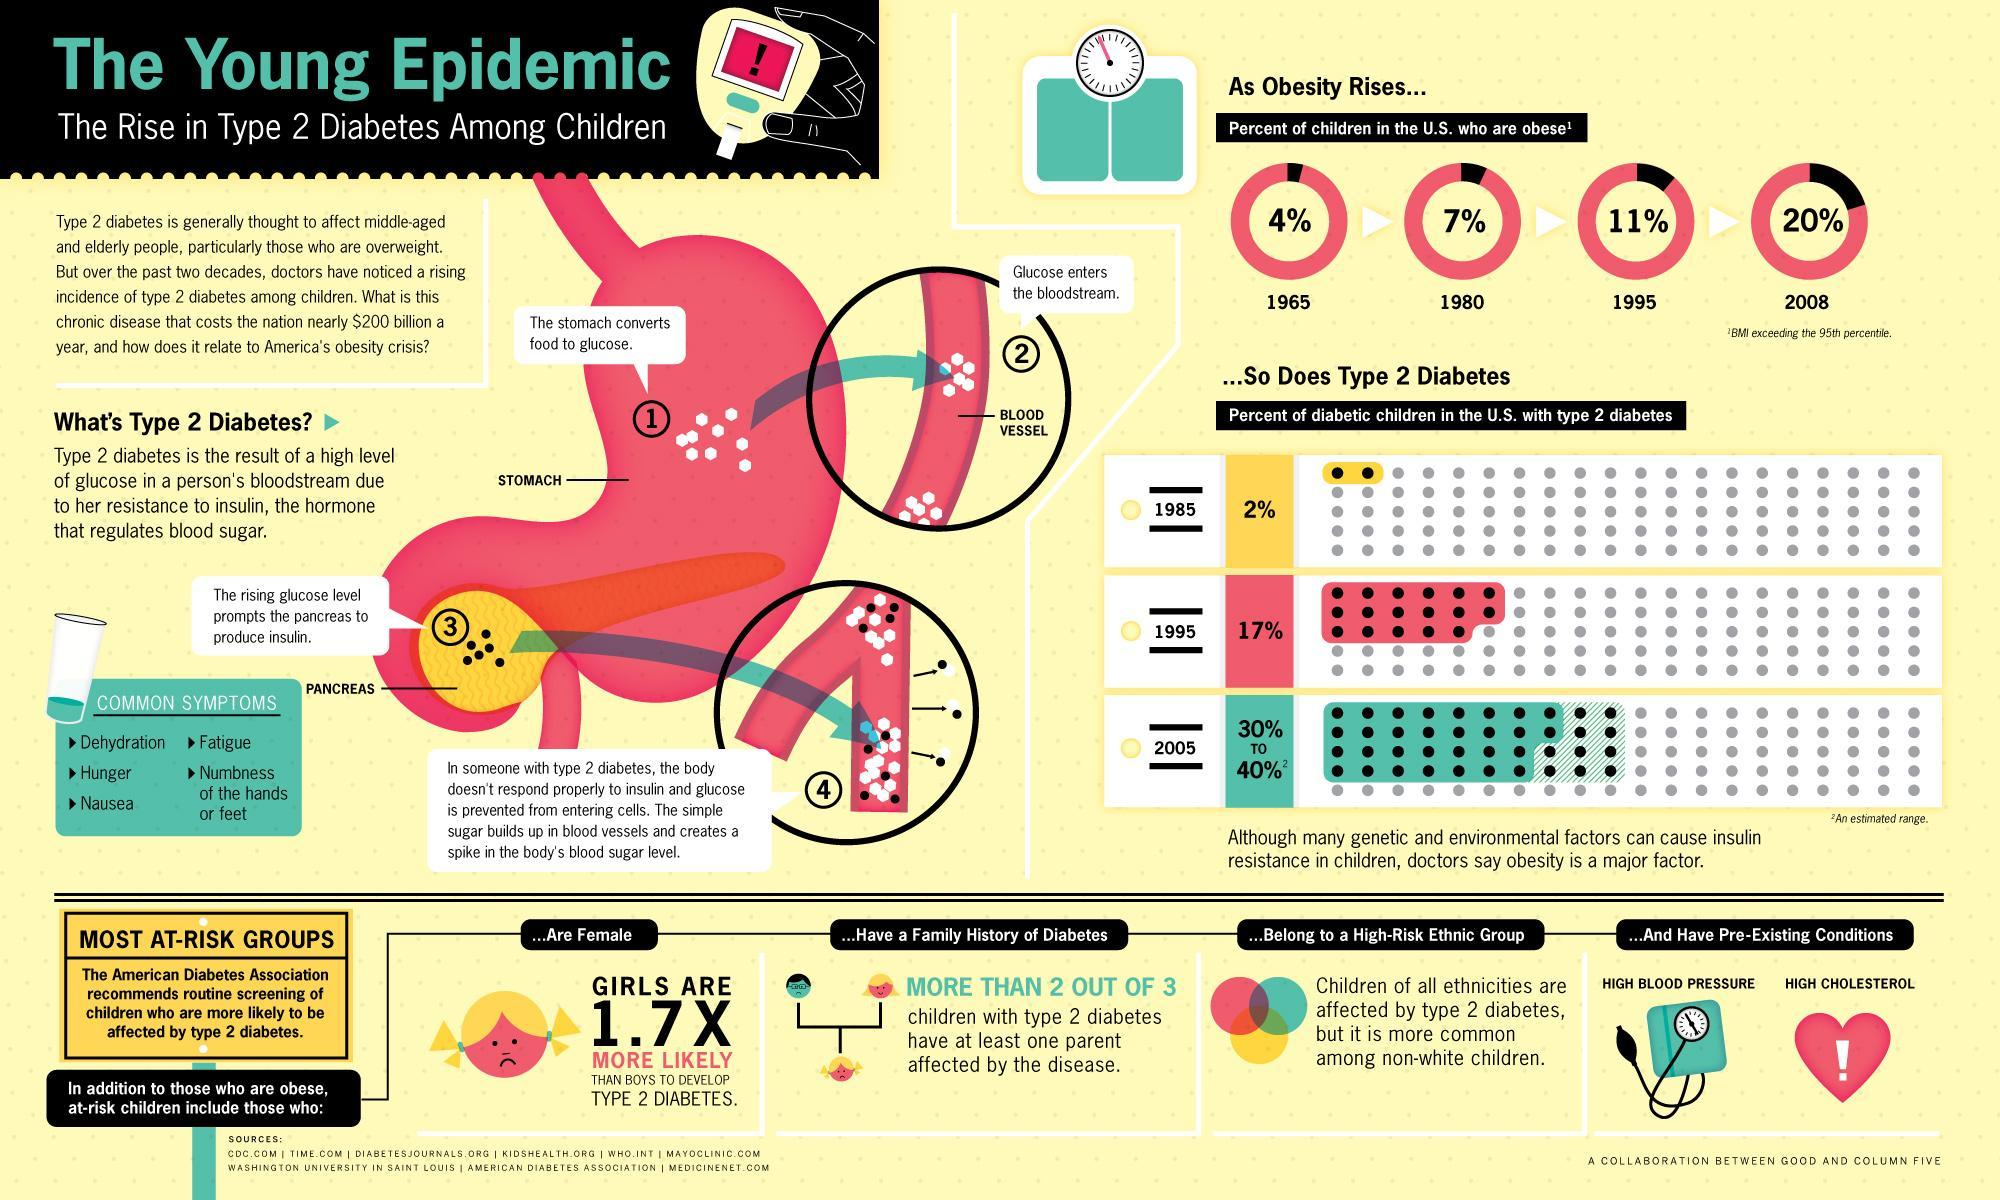In which year, the percent of diabetic children in the U.S. with type 2- diabetes is 17%?
Answer the question with a short phrase. 1995 In which year, the percent of diabetic children in the U.S. with type 2- diabetes is 30-40%? 2005 Which ethnic group of children in U.S. is more likely to develop type 2- diabetes? non-white children What is the major factor for causing type 2- diabetes in children? Obesity What percentage of children in the U.S. are not obese in 2008? 80% What is the percentage of obese children in the U.S. in 1995? 11% Which organ produces insulin in human body? pancreas Which pre-existing conditions can lead to type 2- diabetes in children? HIGH BLOOD PRESSURE, HIGH CHOLESTEROL What percentage of children in the U.S. are not obese in 1980? 93% What is the percentage of obese children in the U.S. in 2008? 20% 